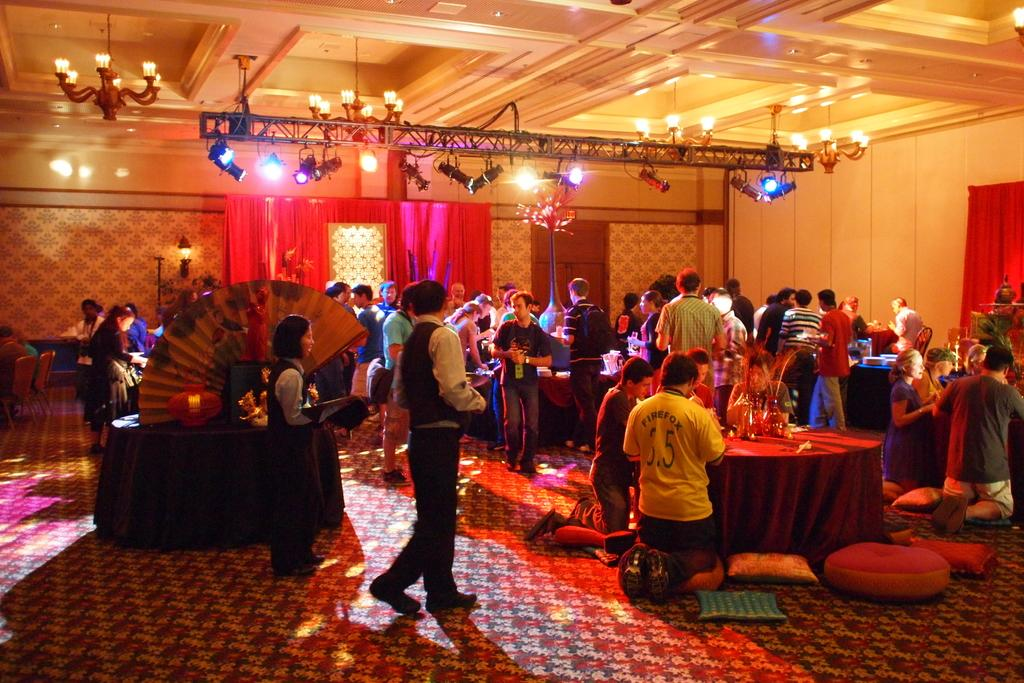How many people are in the image? There is a group of people in the image. What are some of the people doing in the image? Some people are standing, some are walking, and some are holding objects. What can be seen in the background of the image? There are many lamps in the image. Where is the cart located in the image? There is no cart present in the image. What type of birth can be seen taking place in the image? There is no birth depicted in the image. 